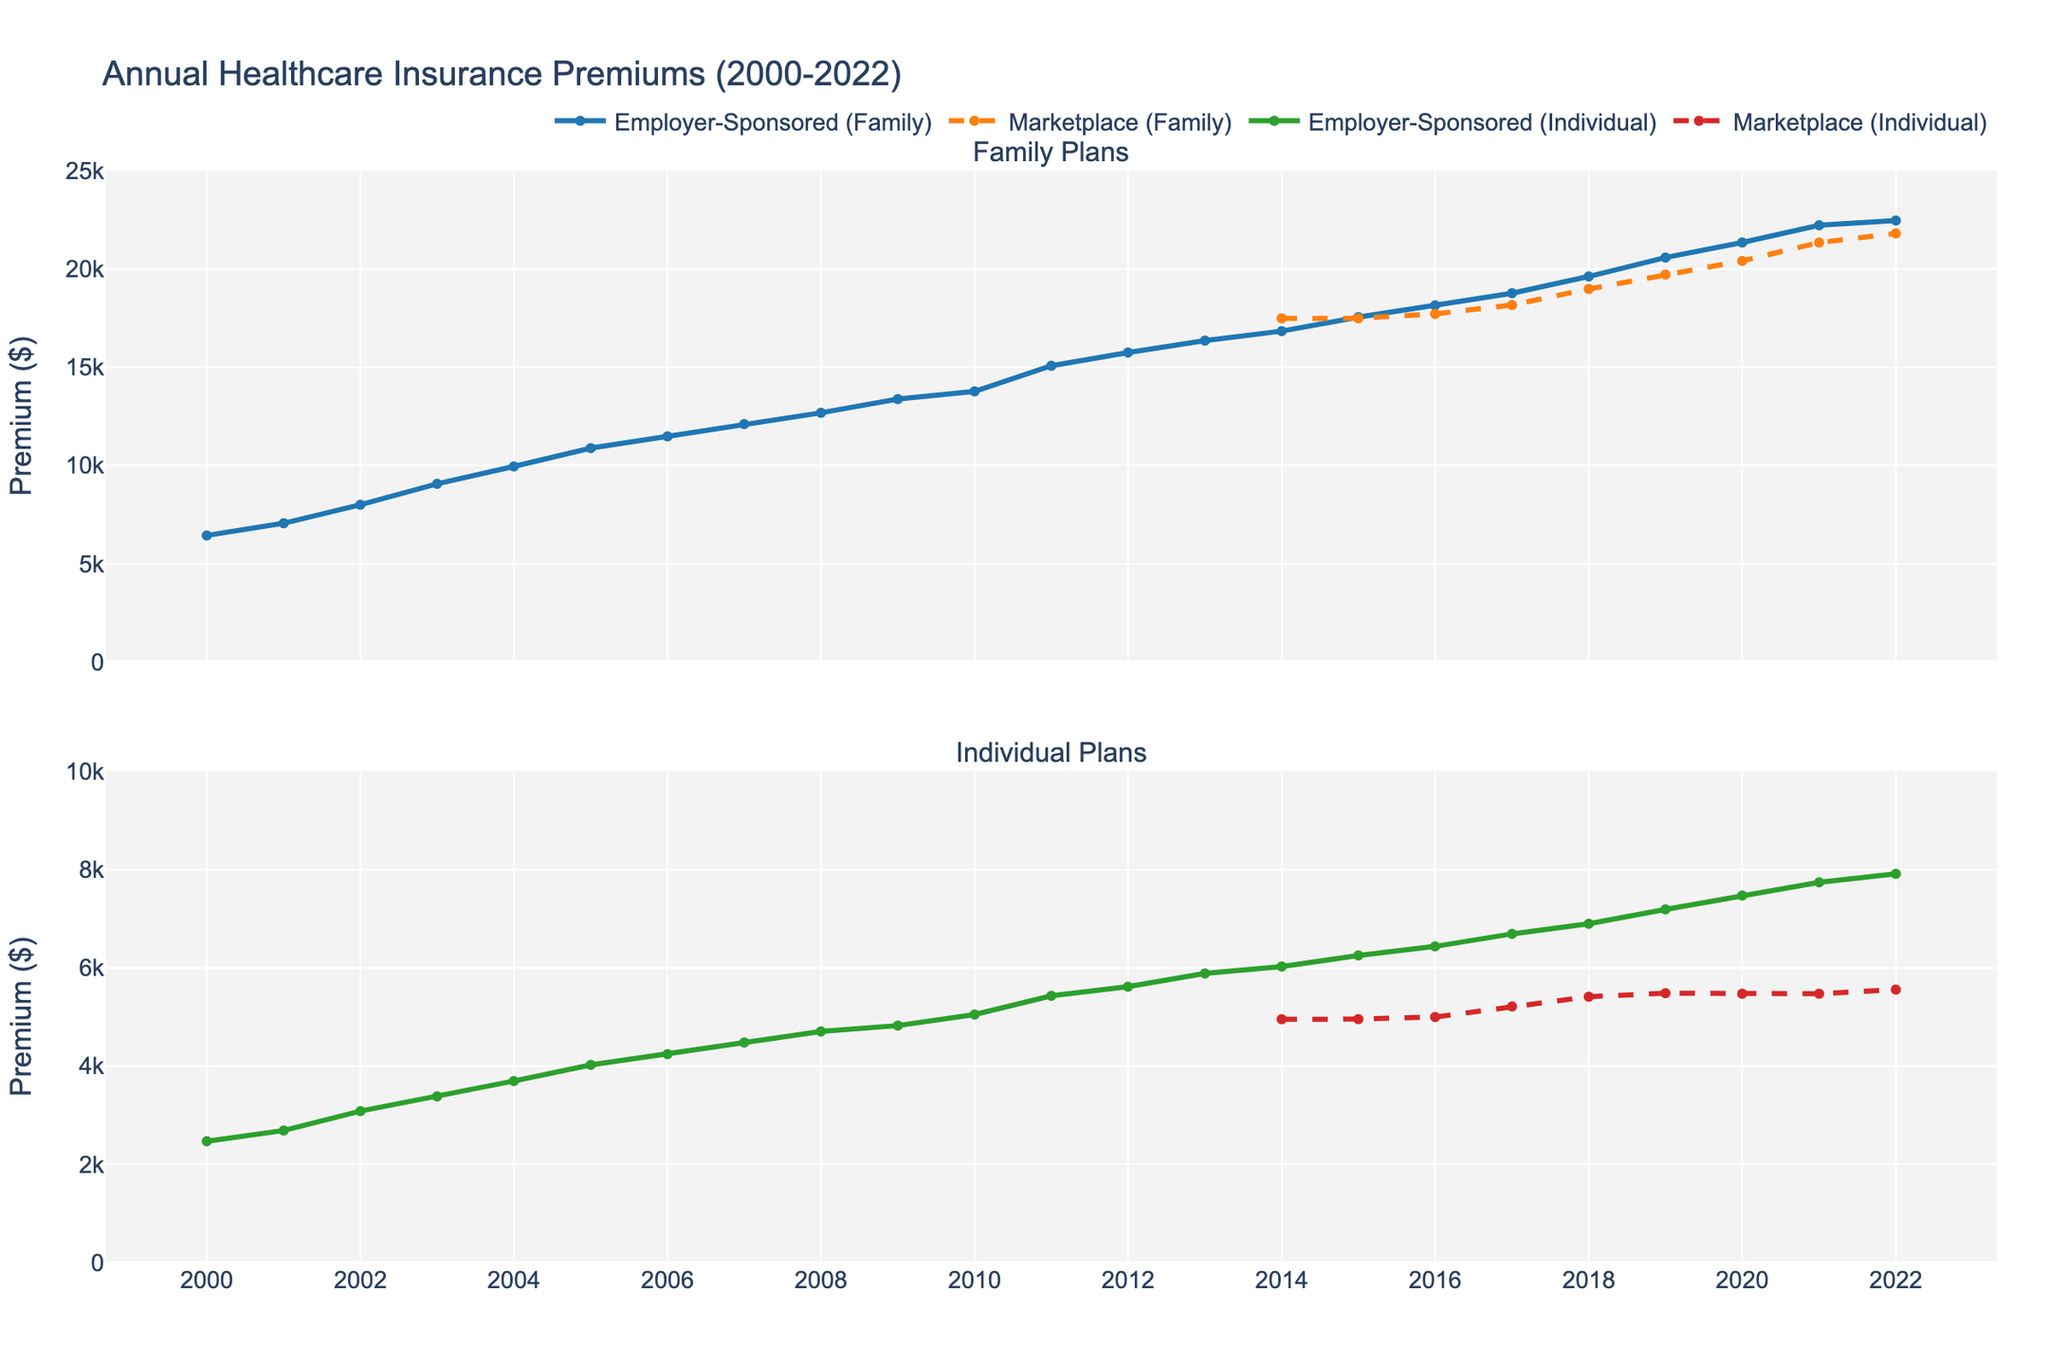What's the general trend of healthcare premiums for family plans under employer-sponsored insurance from 2000 to 2022? The line representing employer-sponsored family plans consistently increases from 2000 to 2022, indicating a rising trend over the years.
Answer: Increasing trend By how much did the healthcare premiums for employer-sponsored individual plans increase from 2000 to 2022? The value for 2000 is $2471, and the value for 2022 is $7911. The increase is $7911 - $2471 = $5440.
Answer: $5440 Did the marketplace family plans ever surpass the employer-sponsored family plans in annual premiums between 2014 and 2022? By visually inspecting the plot, the employer-sponsored family plans consistently show higher premiums compared to marketplace family plans from 2014 to 2022.
Answer: No What is the difference between the highest annual premiums for employer-sponsored family plans and marketplace family plans in the year 2022? In 2022, the highest employer-sponsored family premiums are $22463, and the marketplace family premiums are $21804. The difference is $22463 - $21804 = $659.
Answer: $659 Which individual plan type had higher premiums in 2018, and by how much? In 2018, employer-sponsored individual plans had premiums of $6896, while marketplace individual plans had premiums of $5411. The difference is $6896 - $5411 = $1485.
Answer: Employer-sponsored by $1485 In 2021, which healthcare premium was exactly equal for both family and individual marketplace plans? In 2021, visually noting, the premiums for individual and family marketplace plans are both $5472.
Answer: $5472 How much did employer-sponsored premiums for family plans increase on average every year between 2000 and 2022? The premiums for family plans in 2000 were $6438, and in 2022, they were $22463. The period is 22 years. Average annual increase = ($22463 - $6438) / 22 ≈ $729.
Answer: $729 Is there any year where the marketplace individual plans saw no change in annual premiums? Marketplace individual premiums remained constant from 2020 to 2021, both at $5472.
Answer: Yes What is the rate of increase in healthcare premiums for family plans in the marketplace from 2014 to 2022? In 2014, marketplace family premiums were $17484, and in 2022, they were $21804. The increase is $21804 - $17484 = $4320 over 8 years. Average rate of increase per year = $4320 / 8 ≈ $540.
Answer: $540 per year By how much is the premium for employer-sponsored individual plans in 2022 higher than that in 2010? In 2010, the premium was $5049, and in 2022 it was $7911. The difference is $7911 - $5049 = $2862.
Answer: $2862 